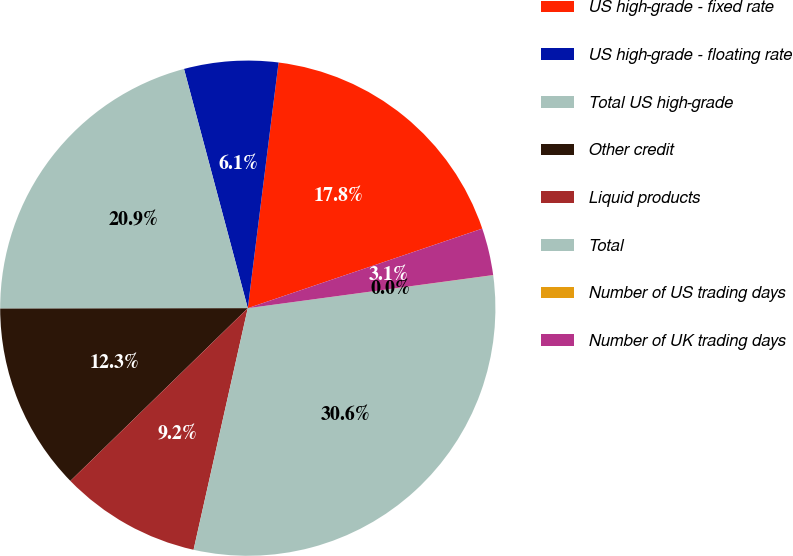Convert chart to OTSL. <chart><loc_0><loc_0><loc_500><loc_500><pie_chart><fcel>US high-grade - fixed rate<fcel>US high-grade - floating rate<fcel>Total US high-grade<fcel>Other credit<fcel>Liquid products<fcel>Total<fcel>Number of US trading days<fcel>Number of UK trading days<nl><fcel>17.81%<fcel>6.13%<fcel>20.88%<fcel>12.26%<fcel>9.2%<fcel>30.64%<fcel>0.01%<fcel>3.07%<nl></chart> 